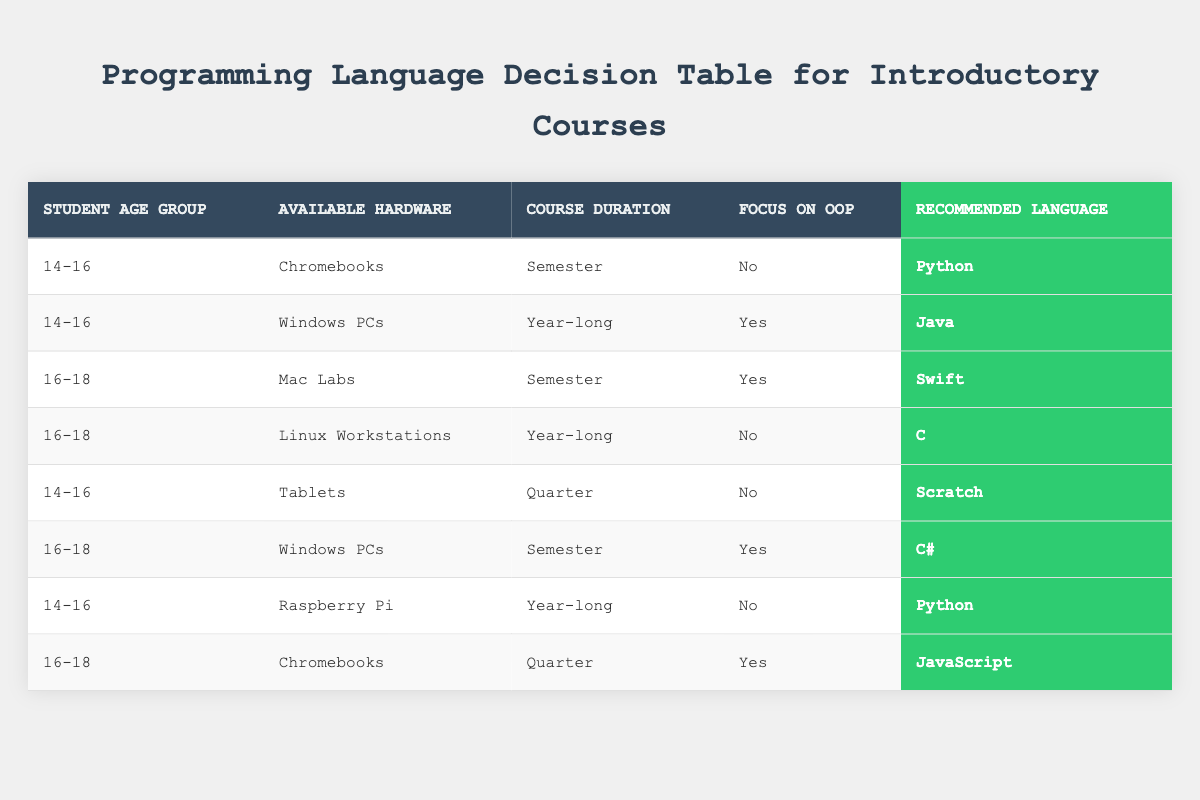What programming language is recommended for students aged 14-16 using Chromebooks and not focused on object-oriented programming? By looking at the first row of the table, it indicates that for students aged 14-16 using Chromebooks with no focus on object-oriented programming, the recommended programming language is Python.
Answer: Python How many programming languages are recommended for students aged 16-18 who focus on object-oriented programming? In the table, there are three entries for students aged 16-18 with a focus on object-oriented programming: Swift (Mac Labs, Semester), C# (Windows PCs, Semester), and JavaScript (Chromebooks, Quarter). Therefore, the total number of different programming languages recommended is three.
Answer: 3 Is Scratch recommended for students aged 14-16 using Tablets? Referring to the fifth row in the table, it shows that for students aged 14-16 using Tablets and with no focus on object-oriented programming, the recommended programming language is Scratch. Hence, it is true that Scratch is recommended in this case.
Answer: Yes Which programming language is recommended for students aged 16-18 using Linux Workstations with no focus on object-oriented programming? The fourth row of the table specifies that for students aged 16-18 using Linux Workstations and with no focus on object-oriented programming, the recommended programming language is C.
Answer: C What is the relationship between available hardware and recommended programming languages for students aged 14-16? By analyzing the rows for students aged 14-16, we can investigate the recommended languages: Python (Chromebooks, Semester), Java (Windows PCs, Year-long), Scratch (Tablets, Quarter), and Python again (Raspberry Pi, Year-long). Python appears twice, but Java and Scratch are unique to their specific hardware. This indicates that the available hardware can influence the language choice, and multiple languages can be suitable for the same age group.
Answer: Available hardware influences language choice How does the course duration affect the recommended programming language for 14-16 year olds? Reviewing the rows for students aged 14-16, we see that for semester course durations (Chromebooks with no OOP), the recommendation is Python; for a year-long (Windows PCs with OOP), it is Java; and for a quarter duration (Tablets with no OOP), it is Scratch. Thus, different durations correspond to differing language suggestions, illustrating that as the course duration changes, the appropriate programming language can also change.
Answer: Course duration influences language choice 